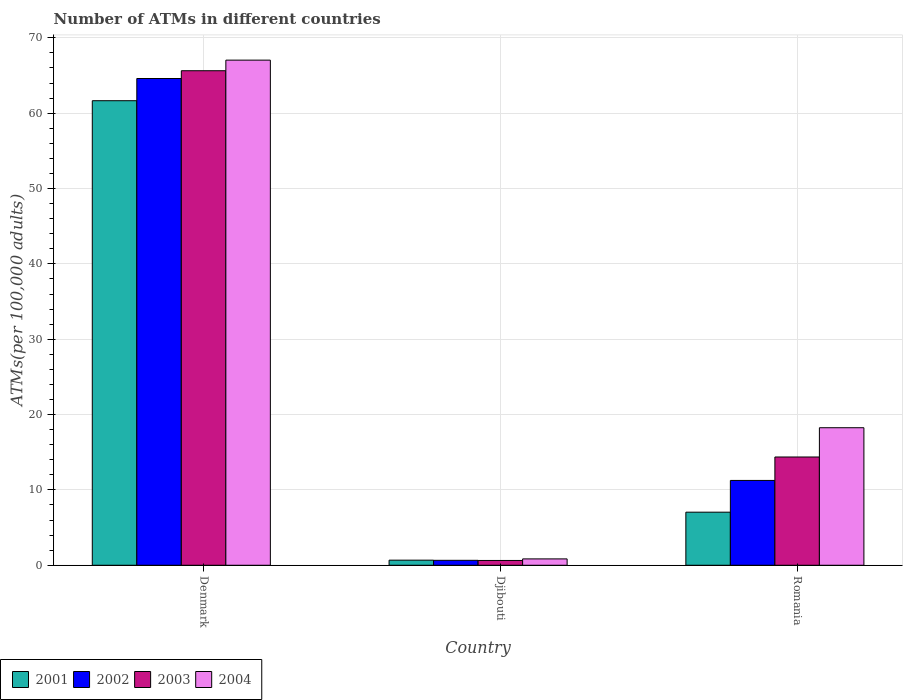How many different coloured bars are there?
Provide a succinct answer. 4. How many groups of bars are there?
Ensure brevity in your answer.  3. How many bars are there on the 1st tick from the left?
Make the answer very short. 4. What is the label of the 2nd group of bars from the left?
Provide a short and direct response. Djibouti. What is the number of ATMs in 2002 in Romania?
Your response must be concise. 11.26. Across all countries, what is the maximum number of ATMs in 2004?
Make the answer very short. 67.04. Across all countries, what is the minimum number of ATMs in 2001?
Your answer should be very brief. 0.68. In which country was the number of ATMs in 2001 maximum?
Your answer should be very brief. Denmark. In which country was the number of ATMs in 2002 minimum?
Provide a short and direct response. Djibouti. What is the total number of ATMs in 2001 in the graph?
Ensure brevity in your answer.  69.38. What is the difference between the number of ATMs in 2002 in Djibouti and that in Romania?
Offer a terse response. -10.6. What is the difference between the number of ATMs in 2002 in Romania and the number of ATMs in 2001 in Djibouti?
Ensure brevity in your answer.  10.58. What is the average number of ATMs in 2001 per country?
Make the answer very short. 23.13. What is the difference between the number of ATMs of/in 2002 and number of ATMs of/in 2004 in Romania?
Ensure brevity in your answer.  -7. In how many countries, is the number of ATMs in 2001 greater than 28?
Your answer should be very brief. 1. What is the ratio of the number of ATMs in 2001 in Denmark to that in Djibouti?
Keep it short and to the point. 91.18. Is the number of ATMs in 2001 in Denmark less than that in Djibouti?
Your answer should be very brief. No. Is the difference between the number of ATMs in 2002 in Denmark and Romania greater than the difference between the number of ATMs in 2004 in Denmark and Romania?
Offer a very short reply. Yes. What is the difference between the highest and the second highest number of ATMs in 2001?
Give a very brief answer. -60.98. What is the difference between the highest and the lowest number of ATMs in 2003?
Your response must be concise. 65. In how many countries, is the number of ATMs in 2001 greater than the average number of ATMs in 2001 taken over all countries?
Offer a very short reply. 1. Is the sum of the number of ATMs in 2004 in Denmark and Romania greater than the maximum number of ATMs in 2002 across all countries?
Ensure brevity in your answer.  Yes. What does the 4th bar from the left in Djibouti represents?
Make the answer very short. 2004. Is it the case that in every country, the sum of the number of ATMs in 2003 and number of ATMs in 2001 is greater than the number of ATMs in 2004?
Your answer should be compact. Yes. What is the difference between two consecutive major ticks on the Y-axis?
Offer a terse response. 10. Where does the legend appear in the graph?
Ensure brevity in your answer.  Bottom left. How are the legend labels stacked?
Provide a short and direct response. Horizontal. What is the title of the graph?
Keep it short and to the point. Number of ATMs in different countries. Does "1978" appear as one of the legend labels in the graph?
Your response must be concise. No. What is the label or title of the X-axis?
Your answer should be very brief. Country. What is the label or title of the Y-axis?
Offer a terse response. ATMs(per 100,0 adults). What is the ATMs(per 100,000 adults) in 2001 in Denmark?
Ensure brevity in your answer.  61.66. What is the ATMs(per 100,000 adults) in 2002 in Denmark?
Provide a short and direct response. 64.61. What is the ATMs(per 100,000 adults) of 2003 in Denmark?
Your answer should be very brief. 65.64. What is the ATMs(per 100,000 adults) of 2004 in Denmark?
Provide a short and direct response. 67.04. What is the ATMs(per 100,000 adults) of 2001 in Djibouti?
Provide a short and direct response. 0.68. What is the ATMs(per 100,000 adults) of 2002 in Djibouti?
Keep it short and to the point. 0.66. What is the ATMs(per 100,000 adults) in 2003 in Djibouti?
Your answer should be very brief. 0.64. What is the ATMs(per 100,000 adults) of 2004 in Djibouti?
Ensure brevity in your answer.  0.84. What is the ATMs(per 100,000 adults) in 2001 in Romania?
Provide a succinct answer. 7.04. What is the ATMs(per 100,000 adults) of 2002 in Romania?
Ensure brevity in your answer.  11.26. What is the ATMs(per 100,000 adults) in 2003 in Romania?
Make the answer very short. 14.37. What is the ATMs(per 100,000 adults) of 2004 in Romania?
Keep it short and to the point. 18.26. Across all countries, what is the maximum ATMs(per 100,000 adults) of 2001?
Ensure brevity in your answer.  61.66. Across all countries, what is the maximum ATMs(per 100,000 adults) of 2002?
Your answer should be compact. 64.61. Across all countries, what is the maximum ATMs(per 100,000 adults) of 2003?
Ensure brevity in your answer.  65.64. Across all countries, what is the maximum ATMs(per 100,000 adults) in 2004?
Offer a terse response. 67.04. Across all countries, what is the minimum ATMs(per 100,000 adults) of 2001?
Offer a terse response. 0.68. Across all countries, what is the minimum ATMs(per 100,000 adults) in 2002?
Your response must be concise. 0.66. Across all countries, what is the minimum ATMs(per 100,000 adults) in 2003?
Give a very brief answer. 0.64. Across all countries, what is the minimum ATMs(per 100,000 adults) of 2004?
Give a very brief answer. 0.84. What is the total ATMs(per 100,000 adults) in 2001 in the graph?
Your answer should be compact. 69.38. What is the total ATMs(per 100,000 adults) in 2002 in the graph?
Make the answer very short. 76.52. What is the total ATMs(per 100,000 adults) of 2003 in the graph?
Make the answer very short. 80.65. What is the total ATMs(per 100,000 adults) in 2004 in the graph?
Provide a succinct answer. 86.14. What is the difference between the ATMs(per 100,000 adults) in 2001 in Denmark and that in Djibouti?
Your answer should be compact. 60.98. What is the difference between the ATMs(per 100,000 adults) of 2002 in Denmark and that in Djibouti?
Give a very brief answer. 63.95. What is the difference between the ATMs(per 100,000 adults) of 2003 in Denmark and that in Djibouti?
Offer a very short reply. 65. What is the difference between the ATMs(per 100,000 adults) of 2004 in Denmark and that in Djibouti?
Give a very brief answer. 66.2. What is the difference between the ATMs(per 100,000 adults) in 2001 in Denmark and that in Romania?
Give a very brief answer. 54.61. What is the difference between the ATMs(per 100,000 adults) of 2002 in Denmark and that in Romania?
Provide a succinct answer. 53.35. What is the difference between the ATMs(per 100,000 adults) in 2003 in Denmark and that in Romania?
Your response must be concise. 51.27. What is the difference between the ATMs(per 100,000 adults) of 2004 in Denmark and that in Romania?
Provide a short and direct response. 48.79. What is the difference between the ATMs(per 100,000 adults) of 2001 in Djibouti and that in Romania?
Ensure brevity in your answer.  -6.37. What is the difference between the ATMs(per 100,000 adults) of 2002 in Djibouti and that in Romania?
Give a very brief answer. -10.6. What is the difference between the ATMs(per 100,000 adults) of 2003 in Djibouti and that in Romania?
Your answer should be very brief. -13.73. What is the difference between the ATMs(per 100,000 adults) in 2004 in Djibouti and that in Romania?
Your answer should be compact. -17.41. What is the difference between the ATMs(per 100,000 adults) of 2001 in Denmark and the ATMs(per 100,000 adults) of 2002 in Djibouti?
Make the answer very short. 61. What is the difference between the ATMs(per 100,000 adults) of 2001 in Denmark and the ATMs(per 100,000 adults) of 2003 in Djibouti?
Provide a short and direct response. 61.02. What is the difference between the ATMs(per 100,000 adults) of 2001 in Denmark and the ATMs(per 100,000 adults) of 2004 in Djibouti?
Make the answer very short. 60.81. What is the difference between the ATMs(per 100,000 adults) of 2002 in Denmark and the ATMs(per 100,000 adults) of 2003 in Djibouti?
Offer a very short reply. 63.97. What is the difference between the ATMs(per 100,000 adults) in 2002 in Denmark and the ATMs(per 100,000 adults) in 2004 in Djibouti?
Provide a short and direct response. 63.76. What is the difference between the ATMs(per 100,000 adults) of 2003 in Denmark and the ATMs(per 100,000 adults) of 2004 in Djibouti?
Your answer should be very brief. 64.79. What is the difference between the ATMs(per 100,000 adults) in 2001 in Denmark and the ATMs(per 100,000 adults) in 2002 in Romania?
Your answer should be compact. 50.4. What is the difference between the ATMs(per 100,000 adults) in 2001 in Denmark and the ATMs(per 100,000 adults) in 2003 in Romania?
Provide a short and direct response. 47.29. What is the difference between the ATMs(per 100,000 adults) of 2001 in Denmark and the ATMs(per 100,000 adults) of 2004 in Romania?
Offer a very short reply. 43.4. What is the difference between the ATMs(per 100,000 adults) of 2002 in Denmark and the ATMs(per 100,000 adults) of 2003 in Romania?
Your response must be concise. 50.24. What is the difference between the ATMs(per 100,000 adults) of 2002 in Denmark and the ATMs(per 100,000 adults) of 2004 in Romania?
Your answer should be compact. 46.35. What is the difference between the ATMs(per 100,000 adults) in 2003 in Denmark and the ATMs(per 100,000 adults) in 2004 in Romania?
Provide a succinct answer. 47.38. What is the difference between the ATMs(per 100,000 adults) in 2001 in Djibouti and the ATMs(per 100,000 adults) in 2002 in Romania?
Your answer should be compact. -10.58. What is the difference between the ATMs(per 100,000 adults) in 2001 in Djibouti and the ATMs(per 100,000 adults) in 2003 in Romania?
Keep it short and to the point. -13.69. What is the difference between the ATMs(per 100,000 adults) in 2001 in Djibouti and the ATMs(per 100,000 adults) in 2004 in Romania?
Provide a short and direct response. -17.58. What is the difference between the ATMs(per 100,000 adults) of 2002 in Djibouti and the ATMs(per 100,000 adults) of 2003 in Romania?
Give a very brief answer. -13.71. What is the difference between the ATMs(per 100,000 adults) in 2002 in Djibouti and the ATMs(per 100,000 adults) in 2004 in Romania?
Offer a very short reply. -17.6. What is the difference between the ATMs(per 100,000 adults) of 2003 in Djibouti and the ATMs(per 100,000 adults) of 2004 in Romania?
Make the answer very short. -17.62. What is the average ATMs(per 100,000 adults) in 2001 per country?
Your answer should be compact. 23.13. What is the average ATMs(per 100,000 adults) of 2002 per country?
Give a very brief answer. 25.51. What is the average ATMs(per 100,000 adults) of 2003 per country?
Offer a terse response. 26.88. What is the average ATMs(per 100,000 adults) of 2004 per country?
Provide a short and direct response. 28.71. What is the difference between the ATMs(per 100,000 adults) in 2001 and ATMs(per 100,000 adults) in 2002 in Denmark?
Your answer should be very brief. -2.95. What is the difference between the ATMs(per 100,000 adults) of 2001 and ATMs(per 100,000 adults) of 2003 in Denmark?
Make the answer very short. -3.98. What is the difference between the ATMs(per 100,000 adults) of 2001 and ATMs(per 100,000 adults) of 2004 in Denmark?
Provide a succinct answer. -5.39. What is the difference between the ATMs(per 100,000 adults) of 2002 and ATMs(per 100,000 adults) of 2003 in Denmark?
Provide a short and direct response. -1.03. What is the difference between the ATMs(per 100,000 adults) of 2002 and ATMs(per 100,000 adults) of 2004 in Denmark?
Offer a very short reply. -2.44. What is the difference between the ATMs(per 100,000 adults) of 2003 and ATMs(per 100,000 adults) of 2004 in Denmark?
Make the answer very short. -1.41. What is the difference between the ATMs(per 100,000 adults) in 2001 and ATMs(per 100,000 adults) in 2002 in Djibouti?
Give a very brief answer. 0.02. What is the difference between the ATMs(per 100,000 adults) of 2001 and ATMs(per 100,000 adults) of 2003 in Djibouti?
Ensure brevity in your answer.  0.04. What is the difference between the ATMs(per 100,000 adults) in 2001 and ATMs(per 100,000 adults) in 2004 in Djibouti?
Provide a short and direct response. -0.17. What is the difference between the ATMs(per 100,000 adults) of 2002 and ATMs(per 100,000 adults) of 2003 in Djibouti?
Keep it short and to the point. 0.02. What is the difference between the ATMs(per 100,000 adults) of 2002 and ATMs(per 100,000 adults) of 2004 in Djibouti?
Offer a terse response. -0.19. What is the difference between the ATMs(per 100,000 adults) in 2003 and ATMs(per 100,000 adults) in 2004 in Djibouti?
Offer a very short reply. -0.21. What is the difference between the ATMs(per 100,000 adults) in 2001 and ATMs(per 100,000 adults) in 2002 in Romania?
Provide a succinct answer. -4.21. What is the difference between the ATMs(per 100,000 adults) of 2001 and ATMs(per 100,000 adults) of 2003 in Romania?
Keep it short and to the point. -7.32. What is the difference between the ATMs(per 100,000 adults) of 2001 and ATMs(per 100,000 adults) of 2004 in Romania?
Your answer should be very brief. -11.21. What is the difference between the ATMs(per 100,000 adults) of 2002 and ATMs(per 100,000 adults) of 2003 in Romania?
Give a very brief answer. -3.11. What is the difference between the ATMs(per 100,000 adults) in 2002 and ATMs(per 100,000 adults) in 2004 in Romania?
Keep it short and to the point. -7. What is the difference between the ATMs(per 100,000 adults) in 2003 and ATMs(per 100,000 adults) in 2004 in Romania?
Ensure brevity in your answer.  -3.89. What is the ratio of the ATMs(per 100,000 adults) of 2001 in Denmark to that in Djibouti?
Give a very brief answer. 91.18. What is the ratio of the ATMs(per 100,000 adults) of 2002 in Denmark to that in Djibouti?
Offer a terse response. 98.45. What is the ratio of the ATMs(per 100,000 adults) in 2003 in Denmark to that in Djibouti?
Offer a terse response. 102.88. What is the ratio of the ATMs(per 100,000 adults) in 2004 in Denmark to that in Djibouti?
Offer a terse response. 79.46. What is the ratio of the ATMs(per 100,000 adults) in 2001 in Denmark to that in Romania?
Your answer should be very brief. 8.75. What is the ratio of the ATMs(per 100,000 adults) in 2002 in Denmark to that in Romania?
Give a very brief answer. 5.74. What is the ratio of the ATMs(per 100,000 adults) in 2003 in Denmark to that in Romania?
Offer a terse response. 4.57. What is the ratio of the ATMs(per 100,000 adults) in 2004 in Denmark to that in Romania?
Your answer should be very brief. 3.67. What is the ratio of the ATMs(per 100,000 adults) of 2001 in Djibouti to that in Romania?
Make the answer very short. 0.1. What is the ratio of the ATMs(per 100,000 adults) in 2002 in Djibouti to that in Romania?
Keep it short and to the point. 0.06. What is the ratio of the ATMs(per 100,000 adults) in 2003 in Djibouti to that in Romania?
Keep it short and to the point. 0.04. What is the ratio of the ATMs(per 100,000 adults) in 2004 in Djibouti to that in Romania?
Give a very brief answer. 0.05. What is the difference between the highest and the second highest ATMs(per 100,000 adults) of 2001?
Provide a short and direct response. 54.61. What is the difference between the highest and the second highest ATMs(per 100,000 adults) of 2002?
Your response must be concise. 53.35. What is the difference between the highest and the second highest ATMs(per 100,000 adults) in 2003?
Your response must be concise. 51.27. What is the difference between the highest and the second highest ATMs(per 100,000 adults) in 2004?
Your answer should be compact. 48.79. What is the difference between the highest and the lowest ATMs(per 100,000 adults) in 2001?
Your response must be concise. 60.98. What is the difference between the highest and the lowest ATMs(per 100,000 adults) of 2002?
Your response must be concise. 63.95. What is the difference between the highest and the lowest ATMs(per 100,000 adults) of 2003?
Give a very brief answer. 65. What is the difference between the highest and the lowest ATMs(per 100,000 adults) in 2004?
Your response must be concise. 66.2. 